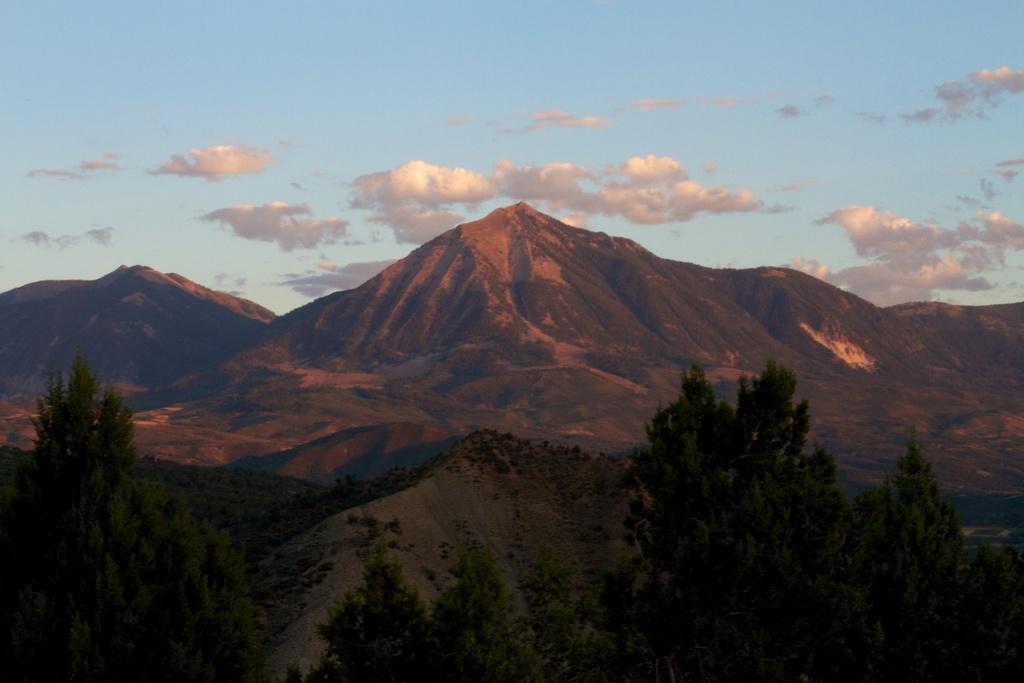How would you summarize this image in a sentence or two? There are trees, mountains and a sky. 